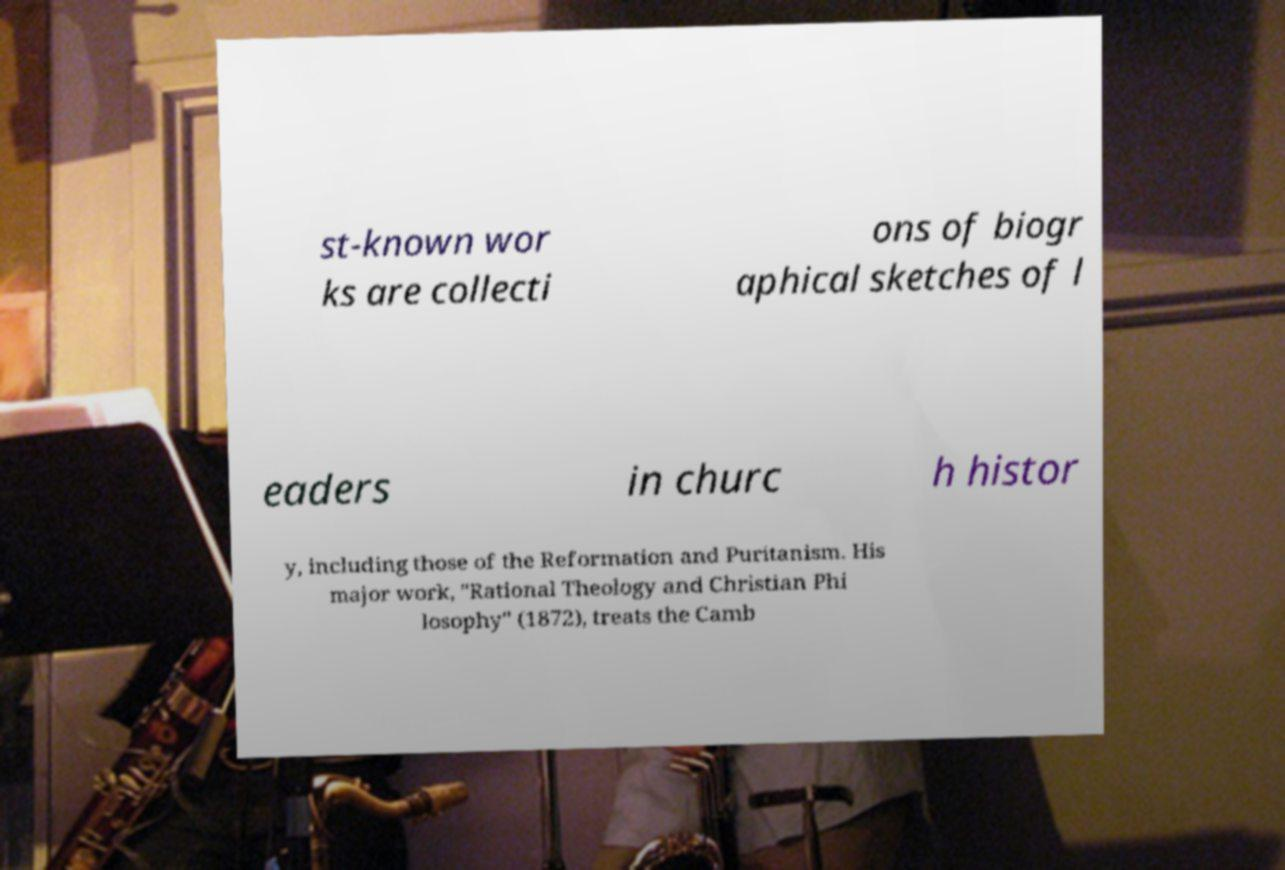Please read and relay the text visible in this image. What does it say? st-known wor ks are collecti ons of biogr aphical sketches of l eaders in churc h histor y, including those of the Reformation and Puritanism. His major work, "Rational Theology and Christian Phi losophy" (1872), treats the Camb 